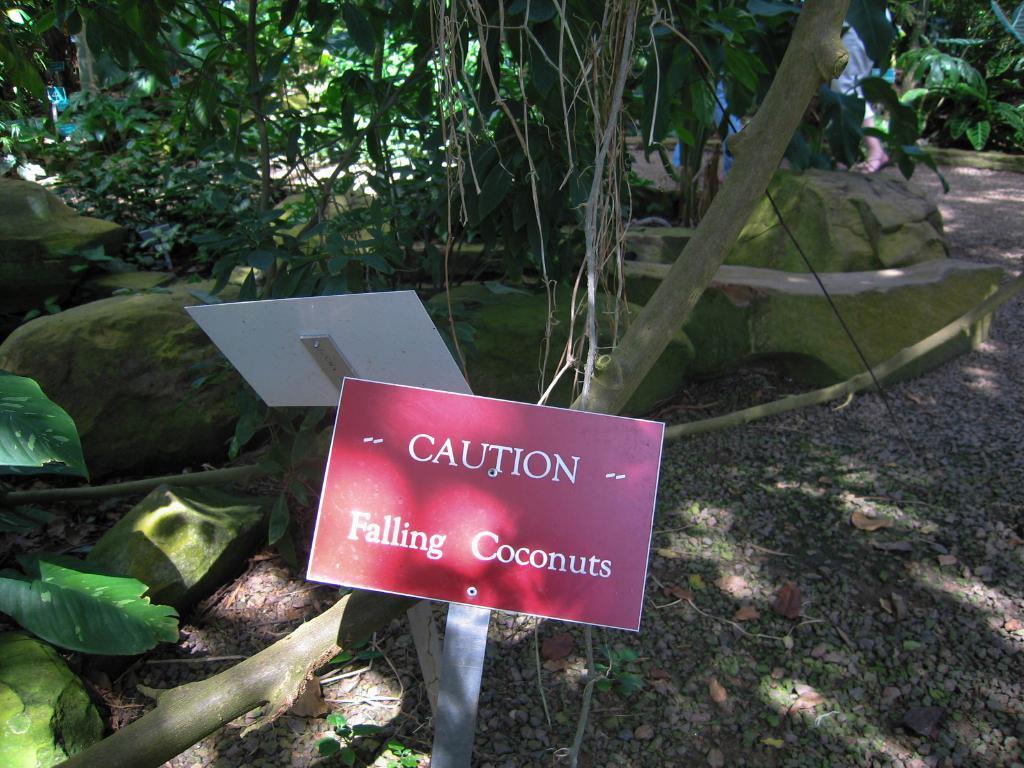In one or two sentences, can you explain what this image depicts? In this image there are boards, and at the background there are rocks, plants, trees, people. 